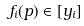<formula> <loc_0><loc_0><loc_500><loc_500>f _ { i } ( p ) \in [ y _ { i } ]</formula> 